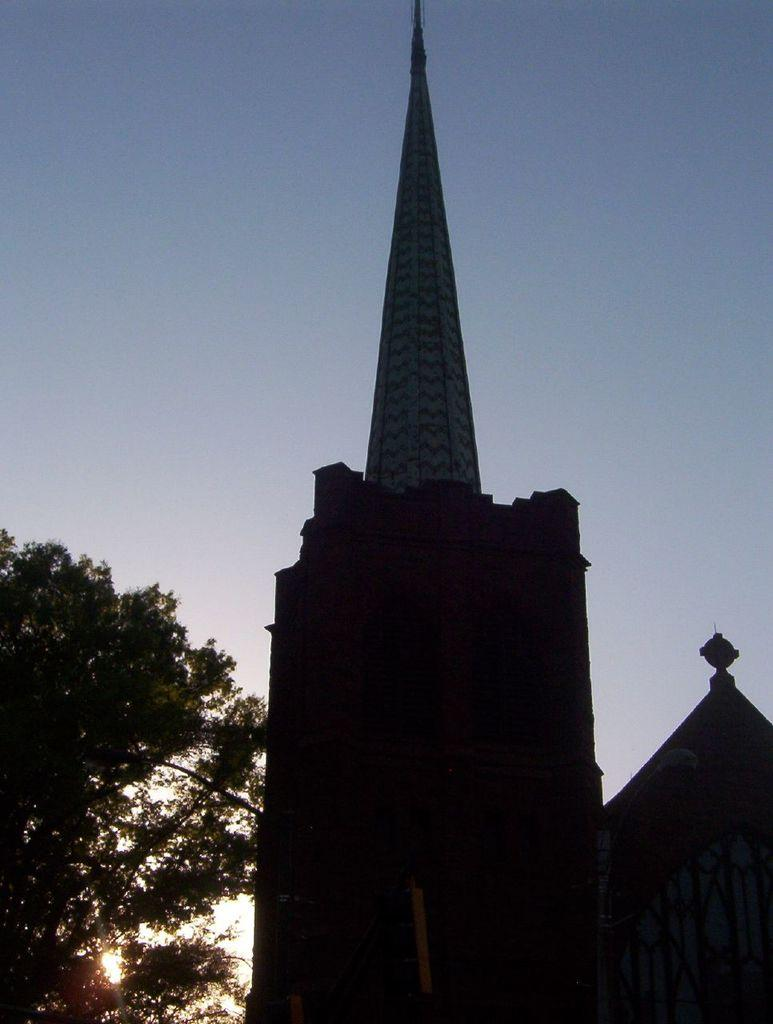What type of structure is visible in the image? There is a building in the image. What can be seen on the left side of the image? There are trees on the left side of the image. What color is the sky in the image? The sky is blue in the image. What type of animal is giving birth in the image? There is no animal or birth event present in the image. Can you describe the haircut of the person in the image? There is no person present in the image, so it is not possible to describe a haircut. 